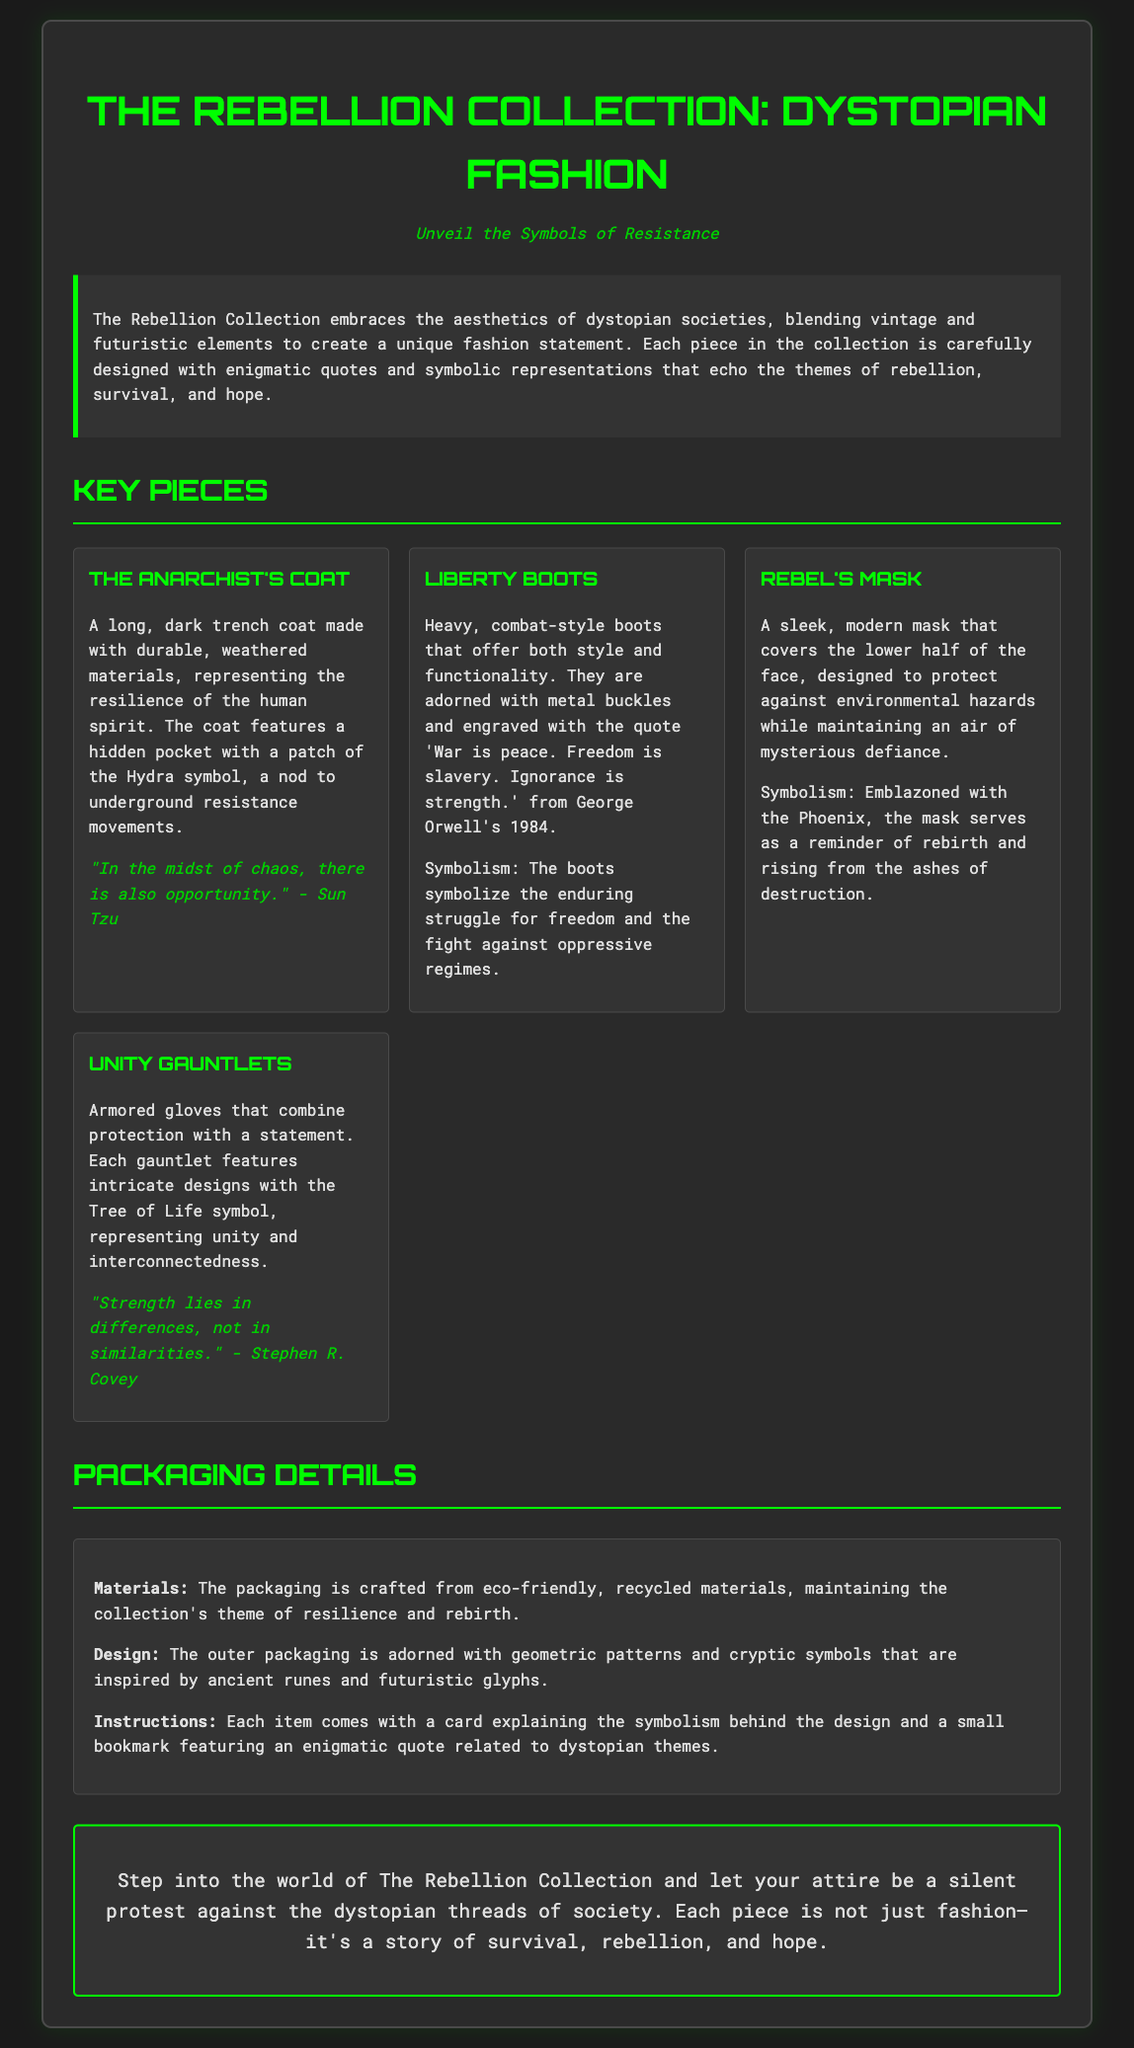What is the title of the collection? The title is presented prominently at the top of the document.
Answer: The Rebellion Collection: Dystopian Fashion What is the theme of The Rebellion Collection? The overview section describes the collection's theme.
Answer: Aesthetics of dystopian societies What material is the packaging made of? The packaging details specify the materials used.
Answer: Eco-friendly, recycled materials What symbol is on The Anarchist's Coat? The description of The Anarchist's Coat mentions a specific symbol.
Answer: Hydra symbol Which quote is featured on the Liberty Boots? The description of the Liberty Boots includes a quote.
Answer: War is peace. Freedom is slavery. Ignorance is strength What is the symbol on the Rebel's Mask? The symbolism explanation for the Rebel's Mask identifies a specific symbol.
Answer: Phoenix How many key pieces are listed in the collection? The number of key pieces is indicated in the section heading.
Answer: Four What is the final message of the document? The final segment summarizes the collection's purpose.
Answer: Silent protest against the dystopian threads of society What does the packaging design include? The packaging details describe the design elements.
Answer: Geometric patterns and cryptic symbols 